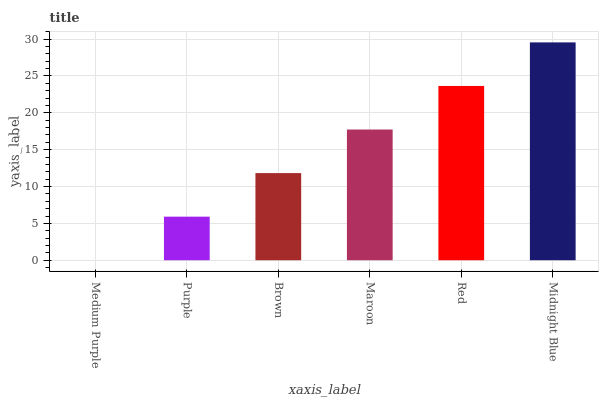Is Purple the minimum?
Answer yes or no. No. Is Purple the maximum?
Answer yes or no. No. Is Purple greater than Medium Purple?
Answer yes or no. Yes. Is Medium Purple less than Purple?
Answer yes or no. Yes. Is Medium Purple greater than Purple?
Answer yes or no. No. Is Purple less than Medium Purple?
Answer yes or no. No. Is Maroon the high median?
Answer yes or no. Yes. Is Brown the low median?
Answer yes or no. Yes. Is Brown the high median?
Answer yes or no. No. Is Red the low median?
Answer yes or no. No. 